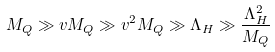<formula> <loc_0><loc_0><loc_500><loc_500>M _ { Q } \gg v M _ { Q } \gg v ^ { 2 } M _ { Q } \gg \Lambda _ { H } \gg \frac { \Lambda _ { H } ^ { 2 } } { M _ { Q } }</formula> 